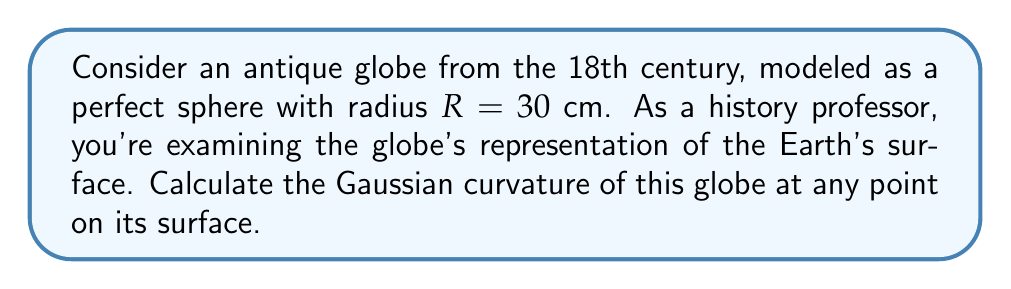Could you help me with this problem? Let's approach this step-by-step:

1) The Gaussian curvature $K$ of a surface is defined as the product of its principal curvatures:

   $K = k_1 \cdot k_2$

   where $k_1$ and $k_2$ are the principal curvatures.

2) For a sphere, the principal curvatures are equal at every point and are given by the reciprocal of the radius:

   $k_1 = k_2 = \frac{1}{R}$

3) Therefore, the Gaussian curvature of a sphere is:

   $K = k_1 \cdot k_2 = \frac{1}{R} \cdot \frac{1}{R} = \frac{1}{R^2}$

4) In this case, we're given that $R = 30$ cm. Let's substitute this value:

   $K = \frac{1}{(30\text{ cm})^2} = \frac{1}{900\text{ cm}^2}$

5) Simplifying:

   $K = \frac{1}{900}\text{ cm}^{-2} \approx 0.001111\text{ cm}^{-2}$

This constant positive Gaussian curvature indicates that the globe is a uniformly curved convex surface, accurately representing the Earth's spherical shape as understood in the 18th century.
Answer: $\frac{1}{900}\text{ cm}^{-2}$ 